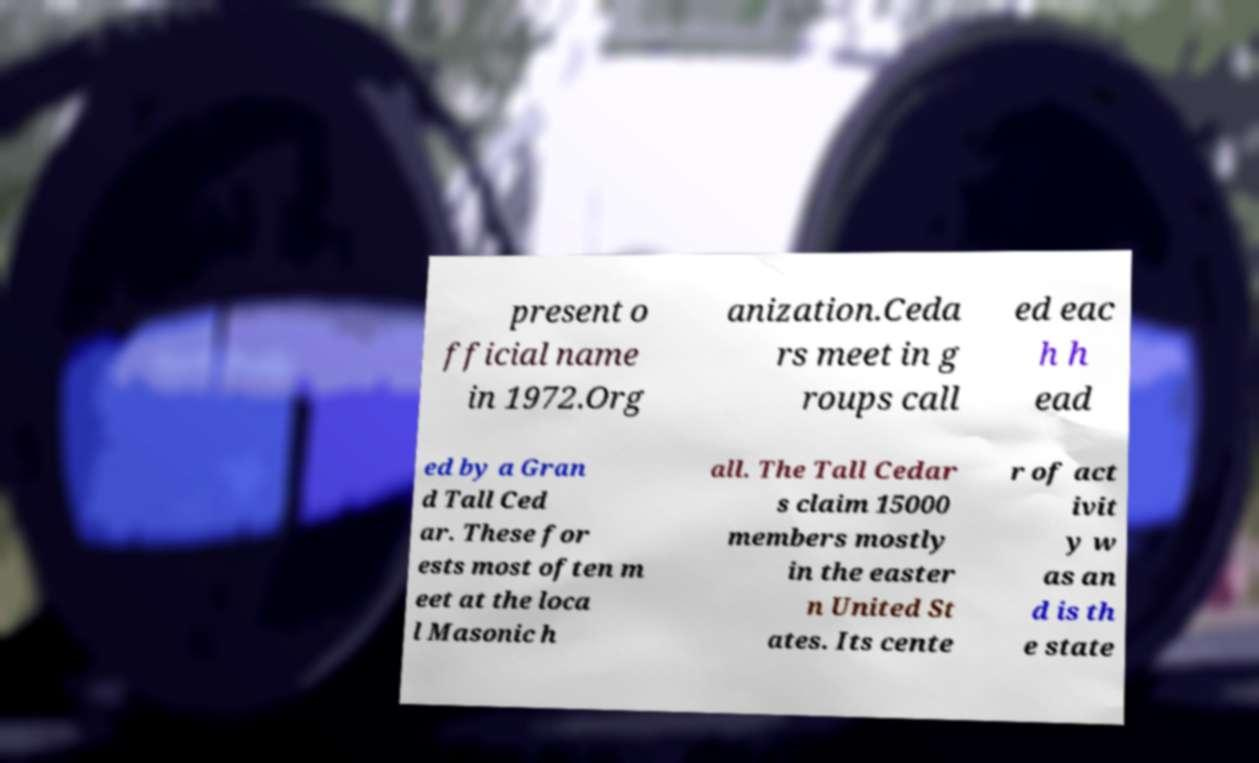Can you accurately transcribe the text from the provided image for me? present o fficial name in 1972.Org anization.Ceda rs meet in g roups call ed eac h h ead ed by a Gran d Tall Ced ar. These for ests most often m eet at the loca l Masonic h all. The Tall Cedar s claim 15000 members mostly in the easter n United St ates. Its cente r of act ivit y w as an d is th e state 